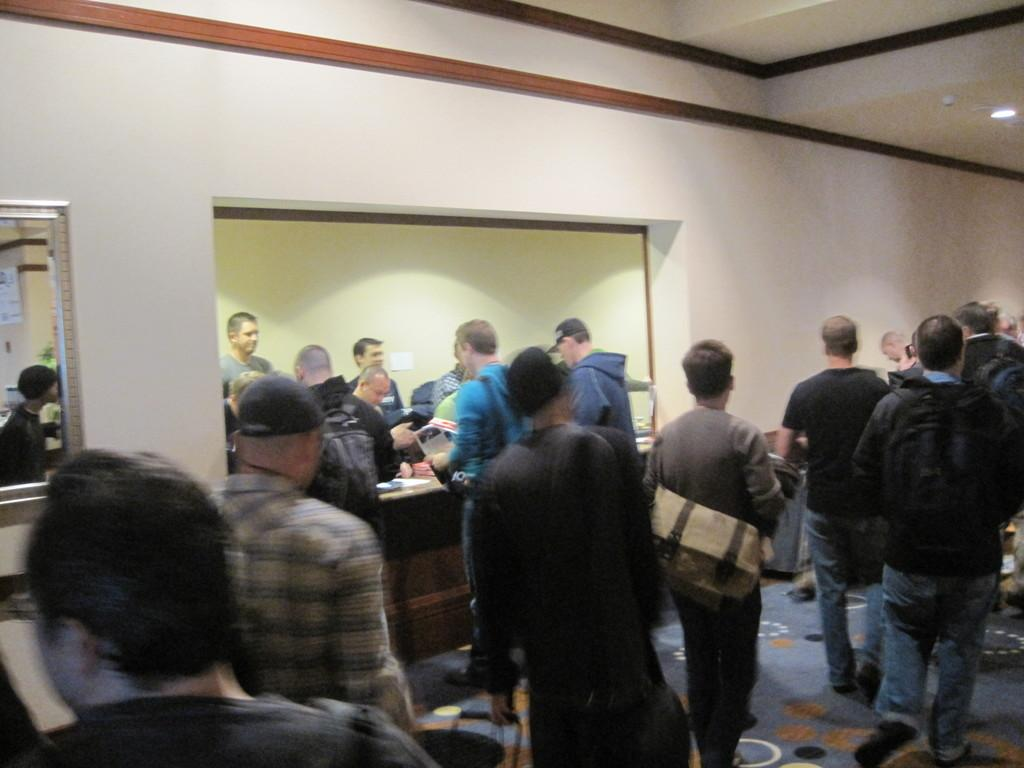What are the persons in the image doing? The persons in the image are on the floor. What is the floor covered with? The floor has a carpet. What is visible in the background of the image? There is a wall in the image. What is providing light in the image? There is a light source in the image. What type of liquid is being spilled on the carpet in the image? There is no liquid being spilled on the carpet in the image. How does the image capture the attention of the viewer? The image itself does not have the ability to capture the attention of the viewer; it is the viewer's personal preference that determines their level of interest. 